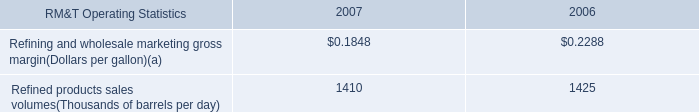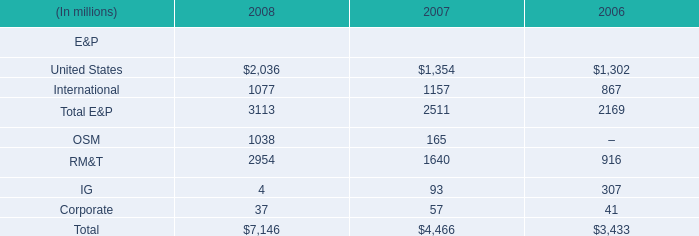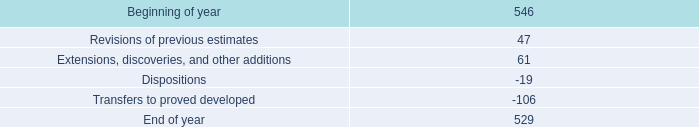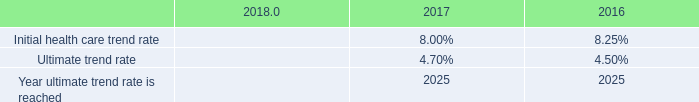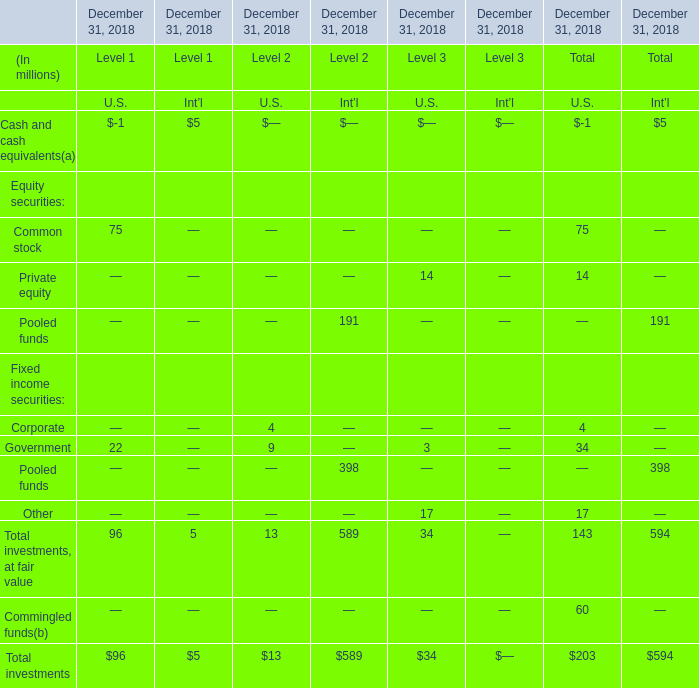what percent of increases in extensions , discoveries , and other additions was associated with the expansion of proved areas and wells to sales from unproved categories in oklahoma? 
Computations: (97 / 116)
Answer: 0.83621. 